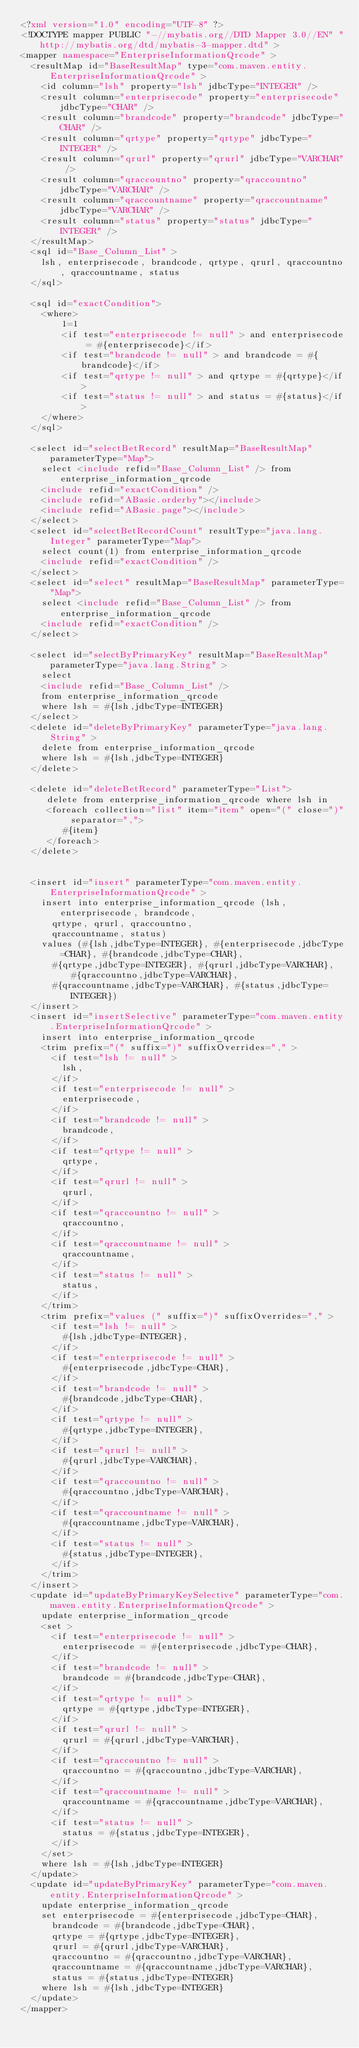<code> <loc_0><loc_0><loc_500><loc_500><_XML_><?xml version="1.0" encoding="UTF-8" ?>
<!DOCTYPE mapper PUBLIC "-//mybatis.org//DTD Mapper 3.0//EN" "http://mybatis.org/dtd/mybatis-3-mapper.dtd" >
<mapper namespace="EnterpriseInformationQrcode" >
  <resultMap id="BaseResultMap" type="com.maven.entity.EnterpriseInformationQrcode" >
    <id column="lsh" property="lsh" jdbcType="INTEGER" />
    <result column="enterprisecode" property="enterprisecode" jdbcType="CHAR" />
    <result column="brandcode" property="brandcode" jdbcType="CHAR" />
    <result column="qrtype" property="qrtype" jdbcType="INTEGER" />
    <result column="qrurl" property="qrurl" jdbcType="VARCHAR" />
    <result column="qraccountno" property="qraccountno" jdbcType="VARCHAR" />
    <result column="qraccountname" property="qraccountname" jdbcType="VARCHAR" />
    <result column="status" property="status" jdbcType="INTEGER" />
  </resultMap>
  <sql id="Base_Column_List" >
    lsh, enterprisecode, brandcode, qrtype, qrurl, qraccountno, qraccountname, status
  </sql>
  
  <sql id="exactCondition">
  	<where> 
  		1=1
		<if test="enterprisecode != null" > and enterprisecode = #{enterprisecode}</if>
		<if test="brandcode != null" > and brandcode = #{brandcode}</if>
		<if test="qrtype != null" > and qrtype = #{qrtype}</if>
		<if test="status != null" > and status = #{status}</if>
	</where>
  </sql>
  
  <select id="selectBetRecord" resultMap="BaseResultMap" parameterType="Map">
  	select <include refid="Base_Column_List" /> from enterprise_information_qrcode
  	<include refid="exactCondition" /> 
  	<include refid="ABasic.orderby"></include> 
  	<include refid="ABasic.page"></include>
  </select>
  <select id="selectBetRecordCount" resultType="java.lang.Integer" parameterType="Map">
  	select count(1) from enterprise_information_qrcode
  	<include refid="exactCondition" />
  </select>
  <select id="select" resultMap="BaseResultMap" parameterType="Map">
  	select <include refid="Base_Column_List" /> from enterprise_information_qrcode
  	<include refid="exactCondition" /> 
  </select>
  
  <select id="selectByPrimaryKey" resultMap="BaseResultMap" parameterType="java.lang.String" >
    select 
    <include refid="Base_Column_List" />
    from enterprise_information_qrcode
    where lsh = #{lsh,jdbcType=INTEGER}
  </select>
  <delete id="deleteByPrimaryKey" parameterType="java.lang.String" >
    delete from enterprise_information_qrcode
    where lsh = #{lsh,jdbcType=INTEGER}
  </delete>
  
  <delete id="deleteBetRecord" parameterType="List">
  	 delete from enterprise_information_qrcode where lsh in
  	 <foreach collection="list" item="item" open="(" close=")" separator=",">
  		#{item}
  	 </foreach>
  </delete>
  
  
  <insert id="insert" parameterType="com.maven.entity.EnterpriseInformationQrcode" >
    insert into enterprise_information_qrcode (lsh, enterprisecode, brandcode, 
      qrtype, qrurl, qraccountno, 
      qraccountname, status)
    values (#{lsh,jdbcType=INTEGER}, #{enterprisecode,jdbcType=CHAR}, #{brandcode,jdbcType=CHAR}, 
      #{qrtype,jdbcType=INTEGER}, #{qrurl,jdbcType=VARCHAR}, #{qraccountno,jdbcType=VARCHAR}, 
      #{qraccountname,jdbcType=VARCHAR}, #{status,jdbcType=INTEGER})
  </insert>
  <insert id="insertSelective" parameterType="com.maven.entity.EnterpriseInformationQrcode" >
    insert into enterprise_information_qrcode
    <trim prefix="(" suffix=")" suffixOverrides="," >
      <if test="lsh != null" >
        lsh,
      </if>
      <if test="enterprisecode != null" >
        enterprisecode,
      </if>
      <if test="brandcode != null" >
        brandcode,
      </if>
      <if test="qrtype != null" >
        qrtype,
      </if>
      <if test="qrurl != null" >
        qrurl,
      </if>
      <if test="qraccountno != null" >
        qraccountno,
      </if>
      <if test="qraccountname != null" >
        qraccountname,
      </if>
      <if test="status != null" >
        status,
      </if>
    </trim>
    <trim prefix="values (" suffix=")" suffixOverrides="," >
      <if test="lsh != null" >
        #{lsh,jdbcType=INTEGER},
      </if>
      <if test="enterprisecode != null" >
        #{enterprisecode,jdbcType=CHAR},
      </if>
      <if test="brandcode != null" >
        #{brandcode,jdbcType=CHAR},
      </if>
      <if test="qrtype != null" >
        #{qrtype,jdbcType=INTEGER},
      </if>
      <if test="qrurl != null" >
        #{qrurl,jdbcType=VARCHAR},
      </if>
      <if test="qraccountno != null" >
        #{qraccountno,jdbcType=VARCHAR},
      </if>
      <if test="qraccountname != null" >
        #{qraccountname,jdbcType=VARCHAR},
      </if>
      <if test="status != null" >
        #{status,jdbcType=INTEGER},
      </if>
    </trim>
  </insert>
  <update id="updateByPrimaryKeySelective" parameterType="com.maven.entity.EnterpriseInformationQrcode" >
    update enterprise_information_qrcode
    <set >
      <if test="enterprisecode != null" >
        enterprisecode = #{enterprisecode,jdbcType=CHAR},
      </if>
      <if test="brandcode != null" >
        brandcode = #{brandcode,jdbcType=CHAR},
      </if>
      <if test="qrtype != null" >
        qrtype = #{qrtype,jdbcType=INTEGER},
      </if>
      <if test="qrurl != null" >
        qrurl = #{qrurl,jdbcType=VARCHAR},
      </if>
      <if test="qraccountno != null" >
        qraccountno = #{qraccountno,jdbcType=VARCHAR},
      </if>
      <if test="qraccountname != null" >
        qraccountname = #{qraccountname,jdbcType=VARCHAR},
      </if>
      <if test="status != null" >
        status = #{status,jdbcType=INTEGER},
      </if>
    </set>
    where lsh = #{lsh,jdbcType=INTEGER}
  </update>
  <update id="updateByPrimaryKey" parameterType="com.maven.entity.EnterpriseInformationQrcode" >
    update enterprise_information_qrcode
    set enterprisecode = #{enterprisecode,jdbcType=CHAR},
      brandcode = #{brandcode,jdbcType=CHAR},
      qrtype = #{qrtype,jdbcType=INTEGER},
      qrurl = #{qrurl,jdbcType=VARCHAR},
      qraccountno = #{qraccountno,jdbcType=VARCHAR},
      qraccountname = #{qraccountname,jdbcType=VARCHAR},
      status = #{status,jdbcType=INTEGER}
    where lsh = #{lsh,jdbcType=INTEGER}
  </update>
</mapper></code> 